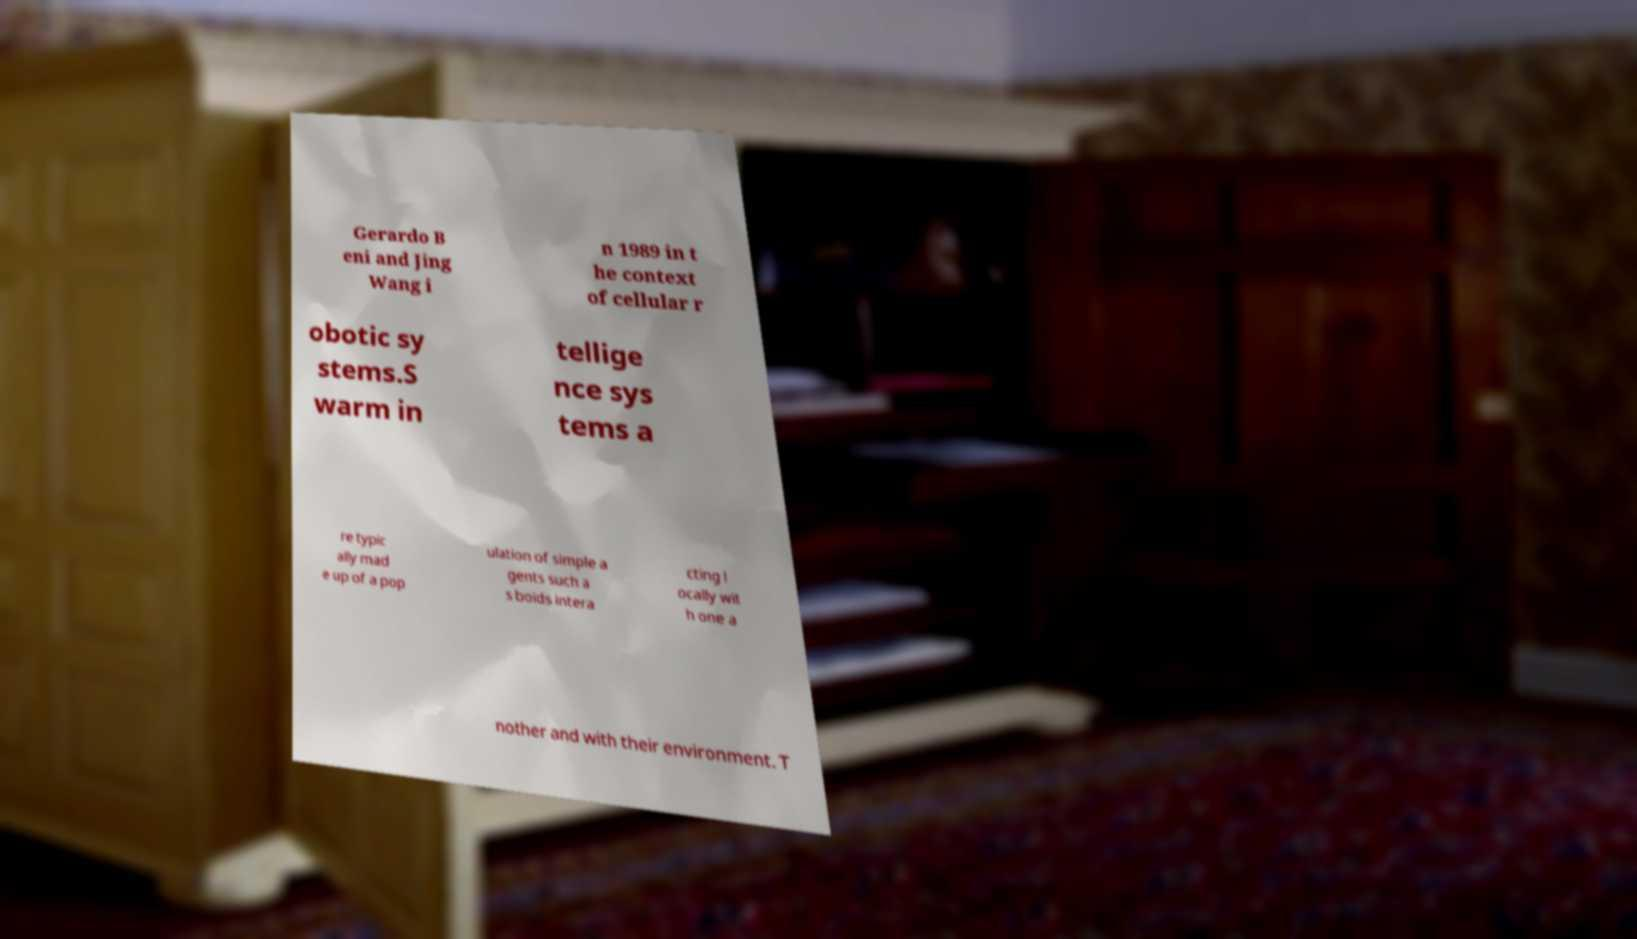What messages or text are displayed in this image? I need them in a readable, typed format. Gerardo B eni and Jing Wang i n 1989 in t he context of cellular r obotic sy stems.S warm in tellige nce sys tems a re typic ally mad e up of a pop ulation of simple a gents such a s boids intera cting l ocally wit h one a nother and with their environment. T 